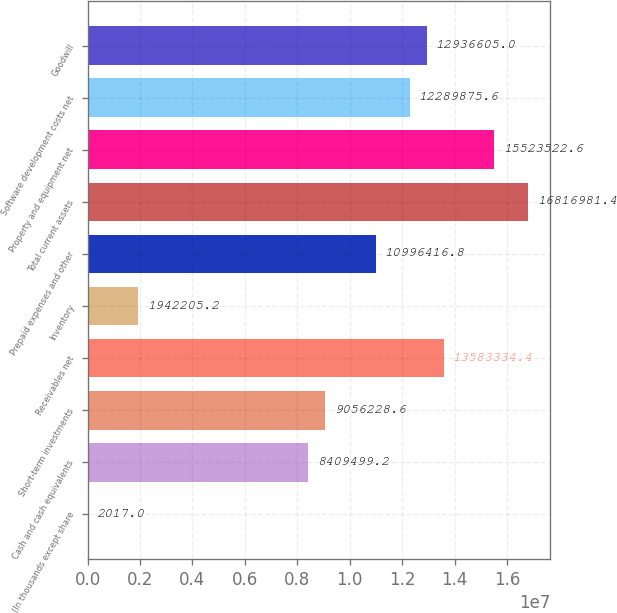Convert chart to OTSL. <chart><loc_0><loc_0><loc_500><loc_500><bar_chart><fcel>(In thousands except share<fcel>Cash and cash equivalents<fcel>Short-term investments<fcel>Receivables net<fcel>Inventory<fcel>Prepaid expenses and other<fcel>Total current assets<fcel>Property and equipment net<fcel>Software development costs net<fcel>Goodwill<nl><fcel>2017<fcel>8.4095e+06<fcel>9.05623e+06<fcel>1.35833e+07<fcel>1.94221e+06<fcel>1.09964e+07<fcel>1.6817e+07<fcel>1.55235e+07<fcel>1.22899e+07<fcel>1.29366e+07<nl></chart> 